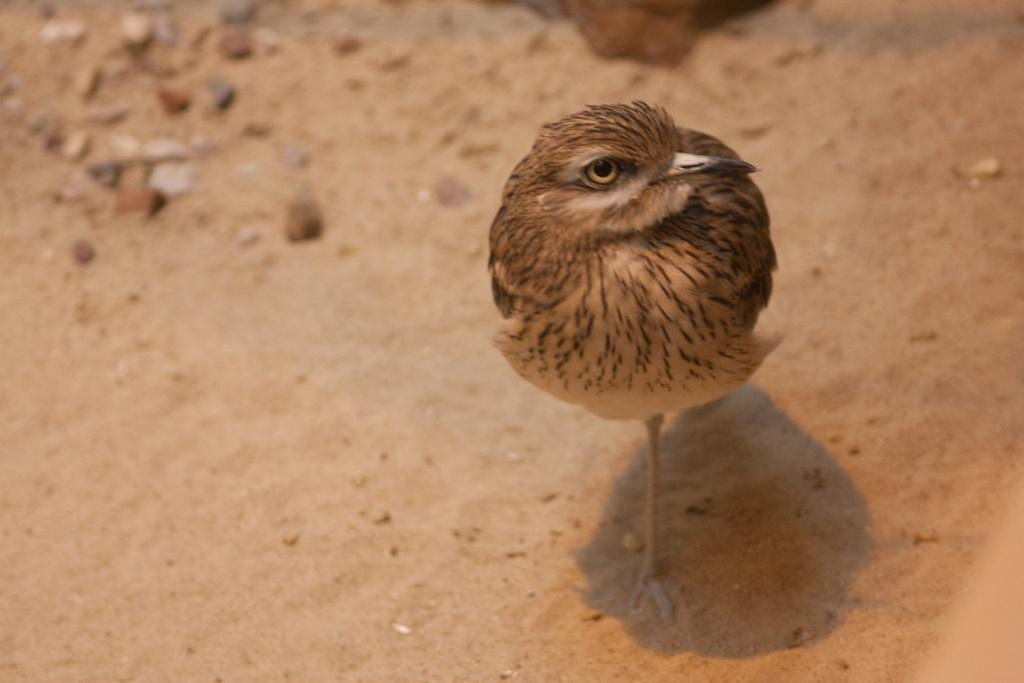What type of animal is in the image? There is a chick in the image. Where is the chick located in the image? The chick is on the ground. Can you describe the position of the chick in the image? The chick is in the center of the image. What type of bead is the chick playing with in the image? There is no bead present in the image; the chick is simply on the ground. 